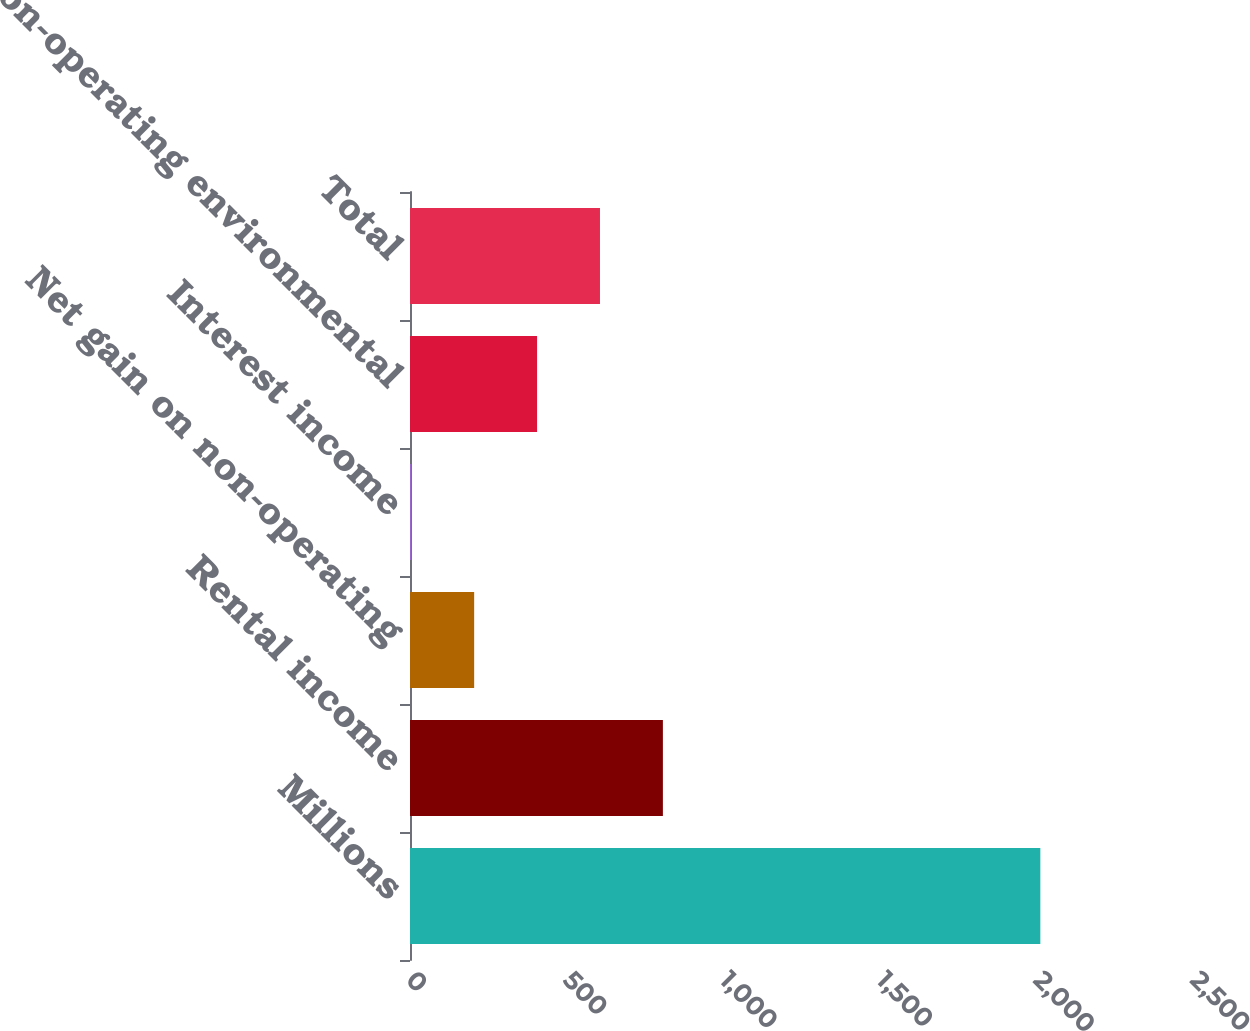Convert chart. <chart><loc_0><loc_0><loc_500><loc_500><bar_chart><fcel>Millions<fcel>Rental income<fcel>Net gain on non-operating<fcel>Interest income<fcel>Non-operating environmental<fcel>Total<nl><fcel>2010<fcel>806.4<fcel>204.6<fcel>4<fcel>405.2<fcel>605.8<nl></chart> 